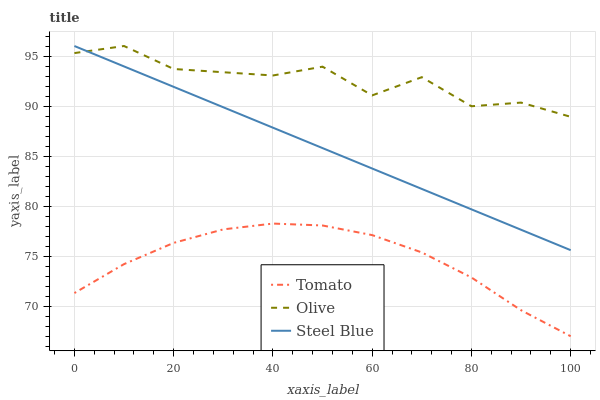Does Steel Blue have the minimum area under the curve?
Answer yes or no. No. Does Steel Blue have the maximum area under the curve?
Answer yes or no. No. Is Olive the smoothest?
Answer yes or no. No. Is Steel Blue the roughest?
Answer yes or no. No. Does Steel Blue have the lowest value?
Answer yes or no. No. Is Tomato less than Steel Blue?
Answer yes or no. Yes. Is Olive greater than Tomato?
Answer yes or no. Yes. Does Tomato intersect Steel Blue?
Answer yes or no. No. 